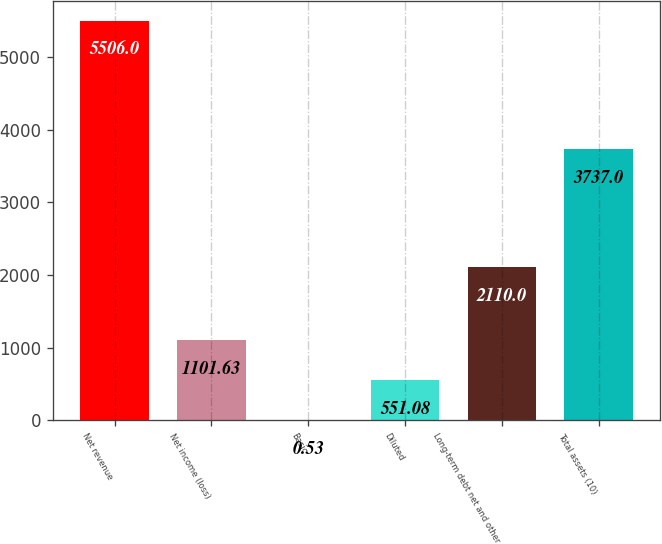Convert chart. <chart><loc_0><loc_0><loc_500><loc_500><bar_chart><fcel>Net revenue<fcel>Net income (loss)<fcel>Basic<fcel>Diluted<fcel>Long-term debt net and other<fcel>Total assets (10)<nl><fcel>5506<fcel>1101.63<fcel>0.53<fcel>551.08<fcel>2110<fcel>3737<nl></chart> 